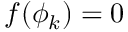<formula> <loc_0><loc_0><loc_500><loc_500>f ( \phi _ { k } ) = 0</formula> 